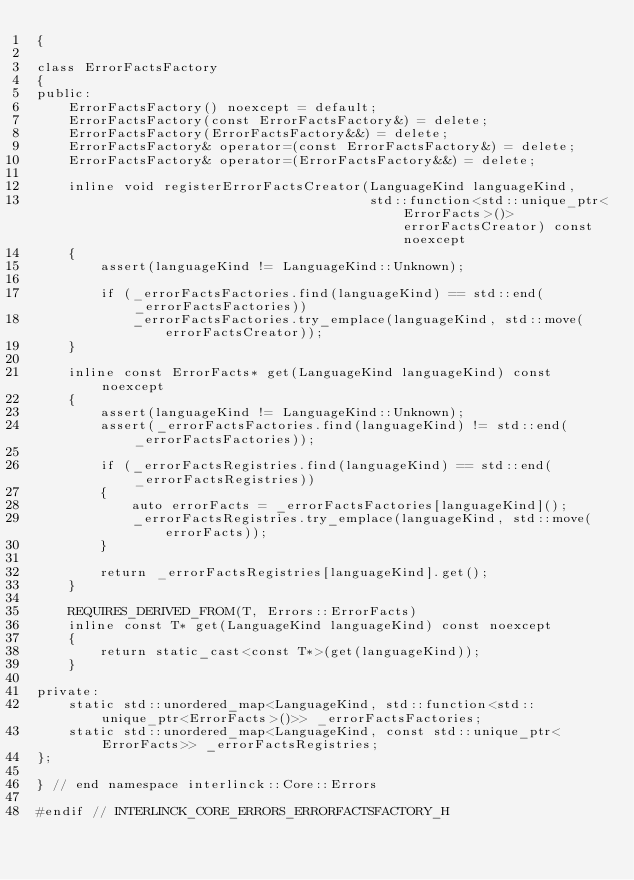Convert code to text. <code><loc_0><loc_0><loc_500><loc_500><_C++_>{

class ErrorFactsFactory
{
public:
    ErrorFactsFactory() noexcept = default;
    ErrorFactsFactory(const ErrorFactsFactory&) = delete;
    ErrorFactsFactory(ErrorFactsFactory&&) = delete;
    ErrorFactsFactory& operator=(const ErrorFactsFactory&) = delete;
    ErrorFactsFactory& operator=(ErrorFactsFactory&&) = delete;

    inline void registerErrorFactsCreator(LanguageKind languageKind,
                                          std::function<std::unique_ptr<ErrorFacts>()> errorFactsCreator) const noexcept
    {
        assert(languageKind != LanguageKind::Unknown);

        if (_errorFactsFactories.find(languageKind) == std::end(_errorFactsFactories))
            _errorFactsFactories.try_emplace(languageKind, std::move(errorFactsCreator));
    }

    inline const ErrorFacts* get(LanguageKind languageKind) const noexcept
    {
        assert(languageKind != LanguageKind::Unknown);
        assert(_errorFactsFactories.find(languageKind) != std::end(_errorFactsFactories));

        if (_errorFactsRegistries.find(languageKind) == std::end(_errorFactsRegistries))
        {
            auto errorFacts = _errorFactsFactories[languageKind]();
            _errorFactsRegistries.try_emplace(languageKind, std::move(errorFacts));
        }

        return _errorFactsRegistries[languageKind].get();
    }

    REQUIRES_DERIVED_FROM(T, Errors::ErrorFacts)
    inline const T* get(LanguageKind languageKind) const noexcept
    {
        return static_cast<const T*>(get(languageKind));
    }

private:
    static std::unordered_map<LanguageKind, std::function<std::unique_ptr<ErrorFacts>()>> _errorFactsFactories;
    static std::unordered_map<LanguageKind, const std::unique_ptr<ErrorFacts>> _errorFactsRegistries;
};

} // end namespace interlinck::Core::Errors

#endif // INTERLINCK_CORE_ERRORS_ERRORFACTSFACTORY_H
</code> 